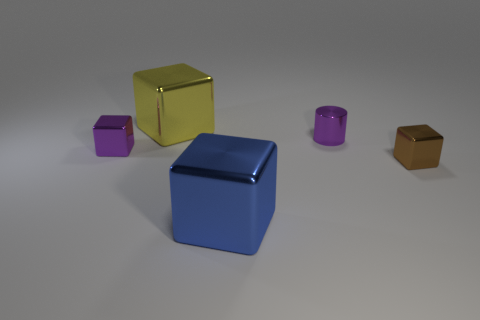What is the color of the cube that is both behind the small brown block and in front of the yellow cube?
Offer a very short reply. Purple. What is the shape of the small metallic object that is the same color as the tiny cylinder?
Your response must be concise. Cube. There is a metal thing in front of the tiny metal block that is on the right side of the tiny purple shiny block; how big is it?
Provide a short and direct response. Large. How many blocks are big blue things or purple things?
Make the answer very short. 2. The thing that is the same size as the yellow metallic cube is what color?
Give a very brief answer. Blue. There is a purple shiny thing that is to the right of the small cube left of the big blue object; what shape is it?
Your response must be concise. Cylinder. There is a purple metallic block on the left side of the blue metallic object; is it the same size as the small brown cube?
Make the answer very short. Yes. How many other objects are there of the same material as the brown object?
Offer a terse response. 4. How many gray objects are either big shiny things or tiny cylinders?
Your response must be concise. 0. What size is the shiny object that is the same color as the tiny cylinder?
Offer a very short reply. Small. 